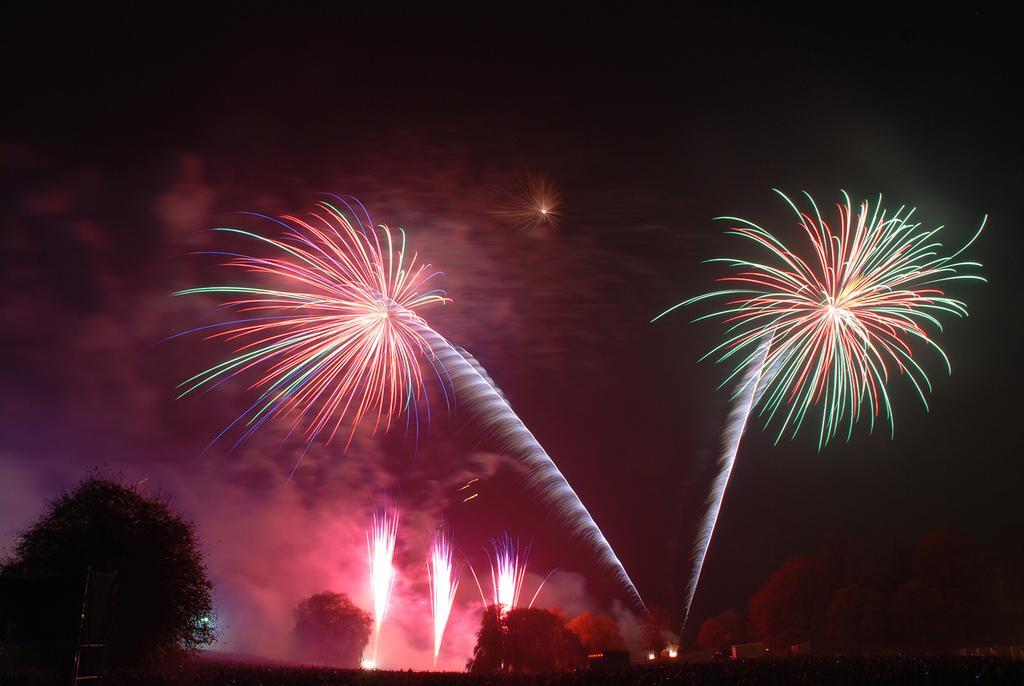Describe this image in one or two sentences. In this picture i can see many firecrackers in the sky. At the bottom i can see many trees and buildings. At the top there is a sky. In the top right there is a darkness. 